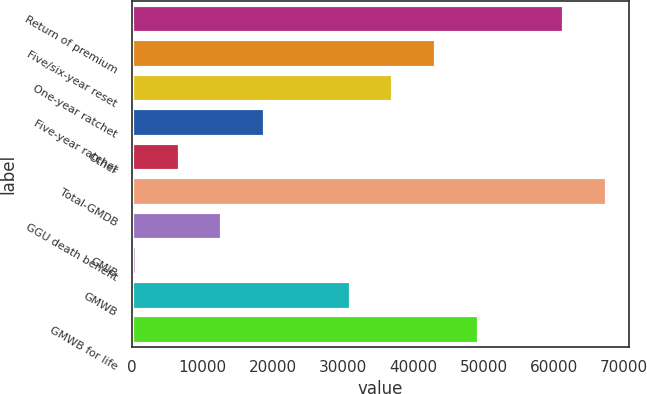<chart> <loc_0><loc_0><loc_500><loc_500><bar_chart><fcel>Return of premium<fcel>Five/six-year reset<fcel>One-year ratchet<fcel>Five-year ratchet<fcel>Other<fcel>Total-GMDB<fcel>GGU death benefit<fcel>GMIB<fcel>GMWB<fcel>GMWB for life<nl><fcel>61290<fcel>43082.1<fcel>37012.8<fcel>18804.9<fcel>6666.3<fcel>67359.3<fcel>12735.6<fcel>597<fcel>30943.5<fcel>49151.4<nl></chart> 